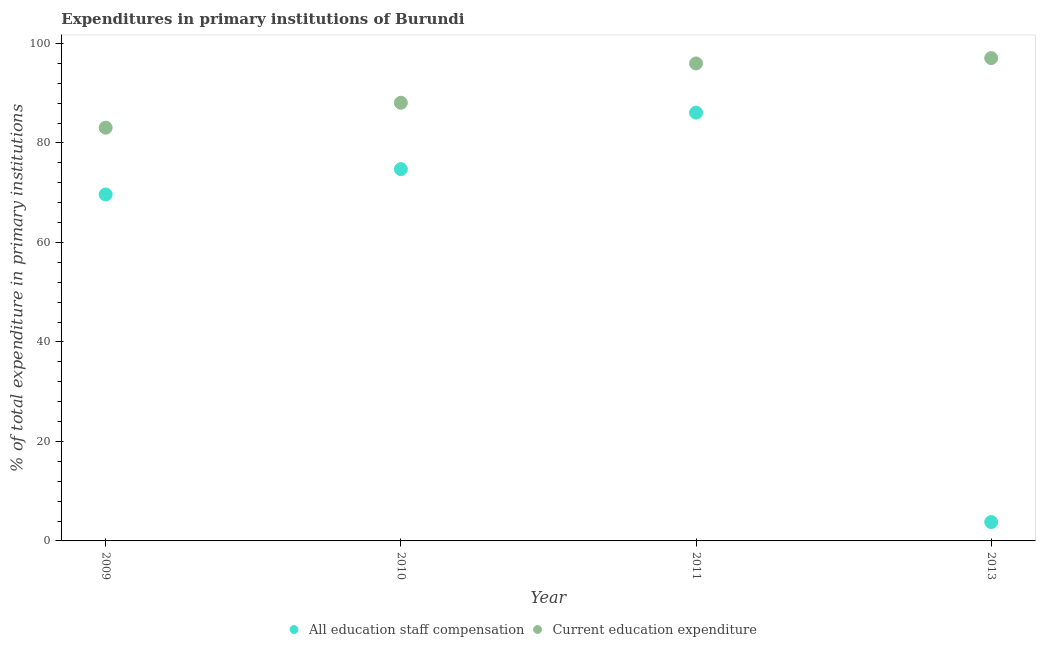Is the number of dotlines equal to the number of legend labels?
Give a very brief answer. Yes. What is the expenditure in staff compensation in 2009?
Give a very brief answer. 69.65. Across all years, what is the maximum expenditure in staff compensation?
Make the answer very short. 86.1. Across all years, what is the minimum expenditure in education?
Your response must be concise. 83.07. In which year was the expenditure in staff compensation maximum?
Your answer should be very brief. 2011. In which year was the expenditure in education minimum?
Give a very brief answer. 2009. What is the total expenditure in staff compensation in the graph?
Your answer should be compact. 234.28. What is the difference between the expenditure in staff compensation in 2009 and that in 2013?
Make the answer very short. 65.86. What is the difference between the expenditure in education in 2011 and the expenditure in staff compensation in 2009?
Your response must be concise. 26.34. What is the average expenditure in education per year?
Your answer should be compact. 91.06. In the year 2013, what is the difference between the expenditure in education and expenditure in staff compensation?
Provide a succinct answer. 93.28. What is the ratio of the expenditure in education in 2010 to that in 2013?
Ensure brevity in your answer.  0.91. Is the expenditure in staff compensation in 2009 less than that in 2010?
Your answer should be compact. Yes. What is the difference between the highest and the second highest expenditure in education?
Offer a very short reply. 1.08. What is the difference between the highest and the lowest expenditure in education?
Give a very brief answer. 14. In how many years, is the expenditure in education greater than the average expenditure in education taken over all years?
Ensure brevity in your answer.  2. Is the sum of the expenditure in staff compensation in 2010 and 2013 greater than the maximum expenditure in education across all years?
Your answer should be very brief. No. Does the expenditure in education monotonically increase over the years?
Your answer should be very brief. Yes. Is the expenditure in education strictly greater than the expenditure in staff compensation over the years?
Provide a succinct answer. Yes. Is the expenditure in staff compensation strictly less than the expenditure in education over the years?
Ensure brevity in your answer.  Yes. How many dotlines are there?
Provide a short and direct response. 2. How many years are there in the graph?
Offer a very short reply. 4. What is the difference between two consecutive major ticks on the Y-axis?
Your answer should be compact. 20. Are the values on the major ticks of Y-axis written in scientific E-notation?
Make the answer very short. No. Does the graph contain any zero values?
Offer a terse response. No. Does the graph contain grids?
Your answer should be very brief. No. Where does the legend appear in the graph?
Your response must be concise. Bottom center. How are the legend labels stacked?
Ensure brevity in your answer.  Horizontal. What is the title of the graph?
Your response must be concise. Expenditures in primary institutions of Burundi. Does "Adolescent fertility rate" appear as one of the legend labels in the graph?
Give a very brief answer. No. What is the label or title of the Y-axis?
Offer a terse response. % of total expenditure in primary institutions. What is the % of total expenditure in primary institutions of All education staff compensation in 2009?
Ensure brevity in your answer.  69.65. What is the % of total expenditure in primary institutions in Current education expenditure in 2009?
Make the answer very short. 83.07. What is the % of total expenditure in primary institutions of All education staff compensation in 2010?
Ensure brevity in your answer.  74.74. What is the % of total expenditure in primary institutions of Current education expenditure in 2010?
Provide a succinct answer. 88.09. What is the % of total expenditure in primary institutions of All education staff compensation in 2011?
Ensure brevity in your answer.  86.1. What is the % of total expenditure in primary institutions of Current education expenditure in 2011?
Offer a very short reply. 96. What is the % of total expenditure in primary institutions of All education staff compensation in 2013?
Your answer should be compact. 3.79. What is the % of total expenditure in primary institutions of Current education expenditure in 2013?
Offer a terse response. 97.07. Across all years, what is the maximum % of total expenditure in primary institutions in All education staff compensation?
Make the answer very short. 86.1. Across all years, what is the maximum % of total expenditure in primary institutions of Current education expenditure?
Ensure brevity in your answer.  97.07. Across all years, what is the minimum % of total expenditure in primary institutions in All education staff compensation?
Make the answer very short. 3.79. Across all years, what is the minimum % of total expenditure in primary institutions of Current education expenditure?
Ensure brevity in your answer.  83.07. What is the total % of total expenditure in primary institutions of All education staff compensation in the graph?
Provide a short and direct response. 234.28. What is the total % of total expenditure in primary institutions of Current education expenditure in the graph?
Your response must be concise. 364.23. What is the difference between the % of total expenditure in primary institutions in All education staff compensation in 2009 and that in 2010?
Ensure brevity in your answer.  -5.09. What is the difference between the % of total expenditure in primary institutions of Current education expenditure in 2009 and that in 2010?
Give a very brief answer. -5.01. What is the difference between the % of total expenditure in primary institutions in All education staff compensation in 2009 and that in 2011?
Your answer should be very brief. -16.45. What is the difference between the % of total expenditure in primary institutions in Current education expenditure in 2009 and that in 2011?
Ensure brevity in your answer.  -12.92. What is the difference between the % of total expenditure in primary institutions in All education staff compensation in 2009 and that in 2013?
Keep it short and to the point. 65.86. What is the difference between the % of total expenditure in primary institutions of Current education expenditure in 2009 and that in 2013?
Offer a very short reply. -14. What is the difference between the % of total expenditure in primary institutions of All education staff compensation in 2010 and that in 2011?
Make the answer very short. -11.36. What is the difference between the % of total expenditure in primary institutions of Current education expenditure in 2010 and that in 2011?
Your answer should be very brief. -7.91. What is the difference between the % of total expenditure in primary institutions in All education staff compensation in 2010 and that in 2013?
Keep it short and to the point. 70.95. What is the difference between the % of total expenditure in primary institutions in Current education expenditure in 2010 and that in 2013?
Give a very brief answer. -8.98. What is the difference between the % of total expenditure in primary institutions in All education staff compensation in 2011 and that in 2013?
Offer a terse response. 82.31. What is the difference between the % of total expenditure in primary institutions of Current education expenditure in 2011 and that in 2013?
Keep it short and to the point. -1.08. What is the difference between the % of total expenditure in primary institutions in All education staff compensation in 2009 and the % of total expenditure in primary institutions in Current education expenditure in 2010?
Keep it short and to the point. -18.44. What is the difference between the % of total expenditure in primary institutions in All education staff compensation in 2009 and the % of total expenditure in primary institutions in Current education expenditure in 2011?
Offer a very short reply. -26.34. What is the difference between the % of total expenditure in primary institutions of All education staff compensation in 2009 and the % of total expenditure in primary institutions of Current education expenditure in 2013?
Your answer should be very brief. -27.42. What is the difference between the % of total expenditure in primary institutions of All education staff compensation in 2010 and the % of total expenditure in primary institutions of Current education expenditure in 2011?
Ensure brevity in your answer.  -21.26. What is the difference between the % of total expenditure in primary institutions of All education staff compensation in 2010 and the % of total expenditure in primary institutions of Current education expenditure in 2013?
Your response must be concise. -22.33. What is the difference between the % of total expenditure in primary institutions of All education staff compensation in 2011 and the % of total expenditure in primary institutions of Current education expenditure in 2013?
Provide a short and direct response. -10.97. What is the average % of total expenditure in primary institutions of All education staff compensation per year?
Give a very brief answer. 58.57. What is the average % of total expenditure in primary institutions in Current education expenditure per year?
Ensure brevity in your answer.  91.06. In the year 2009, what is the difference between the % of total expenditure in primary institutions of All education staff compensation and % of total expenditure in primary institutions of Current education expenditure?
Your answer should be very brief. -13.42. In the year 2010, what is the difference between the % of total expenditure in primary institutions of All education staff compensation and % of total expenditure in primary institutions of Current education expenditure?
Your answer should be compact. -13.35. In the year 2011, what is the difference between the % of total expenditure in primary institutions in All education staff compensation and % of total expenditure in primary institutions in Current education expenditure?
Provide a succinct answer. -9.9. In the year 2013, what is the difference between the % of total expenditure in primary institutions of All education staff compensation and % of total expenditure in primary institutions of Current education expenditure?
Your answer should be very brief. -93.28. What is the ratio of the % of total expenditure in primary institutions in All education staff compensation in 2009 to that in 2010?
Provide a short and direct response. 0.93. What is the ratio of the % of total expenditure in primary institutions of Current education expenditure in 2009 to that in 2010?
Offer a very short reply. 0.94. What is the ratio of the % of total expenditure in primary institutions in All education staff compensation in 2009 to that in 2011?
Offer a very short reply. 0.81. What is the ratio of the % of total expenditure in primary institutions of Current education expenditure in 2009 to that in 2011?
Make the answer very short. 0.87. What is the ratio of the % of total expenditure in primary institutions in All education staff compensation in 2009 to that in 2013?
Keep it short and to the point. 18.38. What is the ratio of the % of total expenditure in primary institutions of Current education expenditure in 2009 to that in 2013?
Provide a succinct answer. 0.86. What is the ratio of the % of total expenditure in primary institutions in All education staff compensation in 2010 to that in 2011?
Your answer should be very brief. 0.87. What is the ratio of the % of total expenditure in primary institutions of Current education expenditure in 2010 to that in 2011?
Make the answer very short. 0.92. What is the ratio of the % of total expenditure in primary institutions in All education staff compensation in 2010 to that in 2013?
Provide a succinct answer. 19.72. What is the ratio of the % of total expenditure in primary institutions in Current education expenditure in 2010 to that in 2013?
Your answer should be very brief. 0.91. What is the ratio of the % of total expenditure in primary institutions of All education staff compensation in 2011 to that in 2013?
Provide a short and direct response. 22.72. What is the ratio of the % of total expenditure in primary institutions of Current education expenditure in 2011 to that in 2013?
Provide a succinct answer. 0.99. What is the difference between the highest and the second highest % of total expenditure in primary institutions in All education staff compensation?
Your answer should be very brief. 11.36. What is the difference between the highest and the second highest % of total expenditure in primary institutions of Current education expenditure?
Provide a succinct answer. 1.08. What is the difference between the highest and the lowest % of total expenditure in primary institutions of All education staff compensation?
Offer a very short reply. 82.31. What is the difference between the highest and the lowest % of total expenditure in primary institutions of Current education expenditure?
Your answer should be compact. 14. 